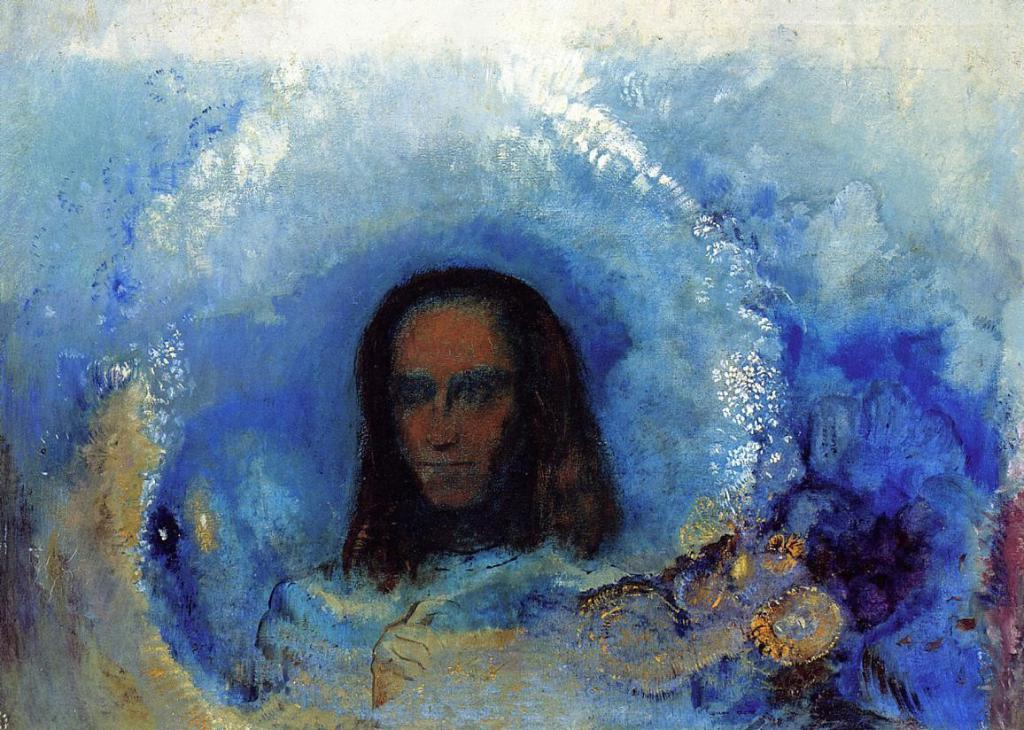What is the main subject of the image? There is a painting of a person in the image. What type of rings does the government provide for the father in the image? There is no mention of rings, government, or a father in the image; it only features a painting of a person. 